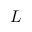Convert formula to latex. <formula><loc_0><loc_0><loc_500><loc_500>L</formula> 